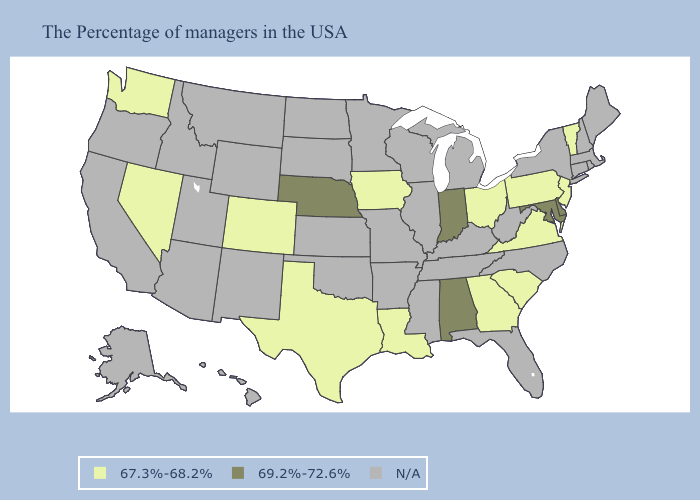Name the states that have a value in the range 69.2%-72.6%?
Be succinct. Delaware, Maryland, Indiana, Alabama, Nebraska. What is the highest value in the MidWest ?
Quick response, please. 69.2%-72.6%. What is the value of Washington?
Quick response, please. 67.3%-68.2%. What is the lowest value in the USA?
Short answer required. 67.3%-68.2%. What is the value of Connecticut?
Answer briefly. N/A. What is the value of Illinois?
Keep it brief. N/A. What is the value of Tennessee?
Short answer required. N/A. Name the states that have a value in the range 67.3%-68.2%?
Give a very brief answer. Vermont, New Jersey, Pennsylvania, Virginia, South Carolina, Ohio, Georgia, Louisiana, Iowa, Texas, Colorado, Nevada, Washington. Among the states that border Georgia , which have the highest value?
Give a very brief answer. Alabama. Does Nebraska have the lowest value in the MidWest?
Concise answer only. No. Does Georgia have the highest value in the USA?
Short answer required. No. 